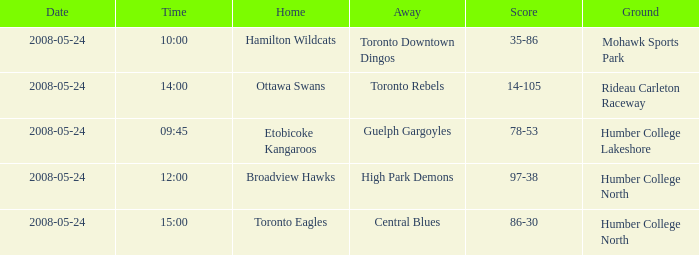On what grounds did the away team of the Toronto Rebels play? Rideau Carleton Raceway. 